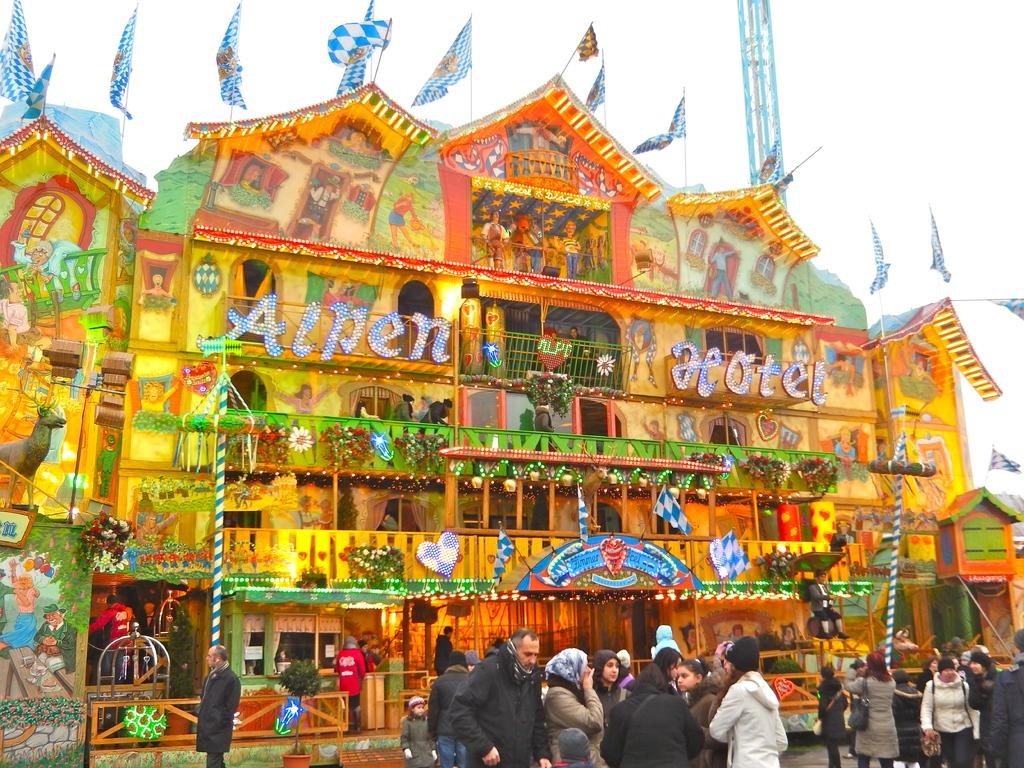What is located in the foreground of the image? There are people in the foreground of the image. What type of structure is depicted in the image? The image appears to depict a decorated building structure. What can be seen flying in the image? There are flags visible in the image. What architectural feature is present in the image? There is a tower in the image. What is visible in the background of the image? The sky is visible in the background of the image. What type of juice is being served at the protest in the image? There is no protest or juice present in the image; it features a decorated building structure with people, flags, and a tower. How many chairs are visible in the image? There are no chairs visible in the image. 